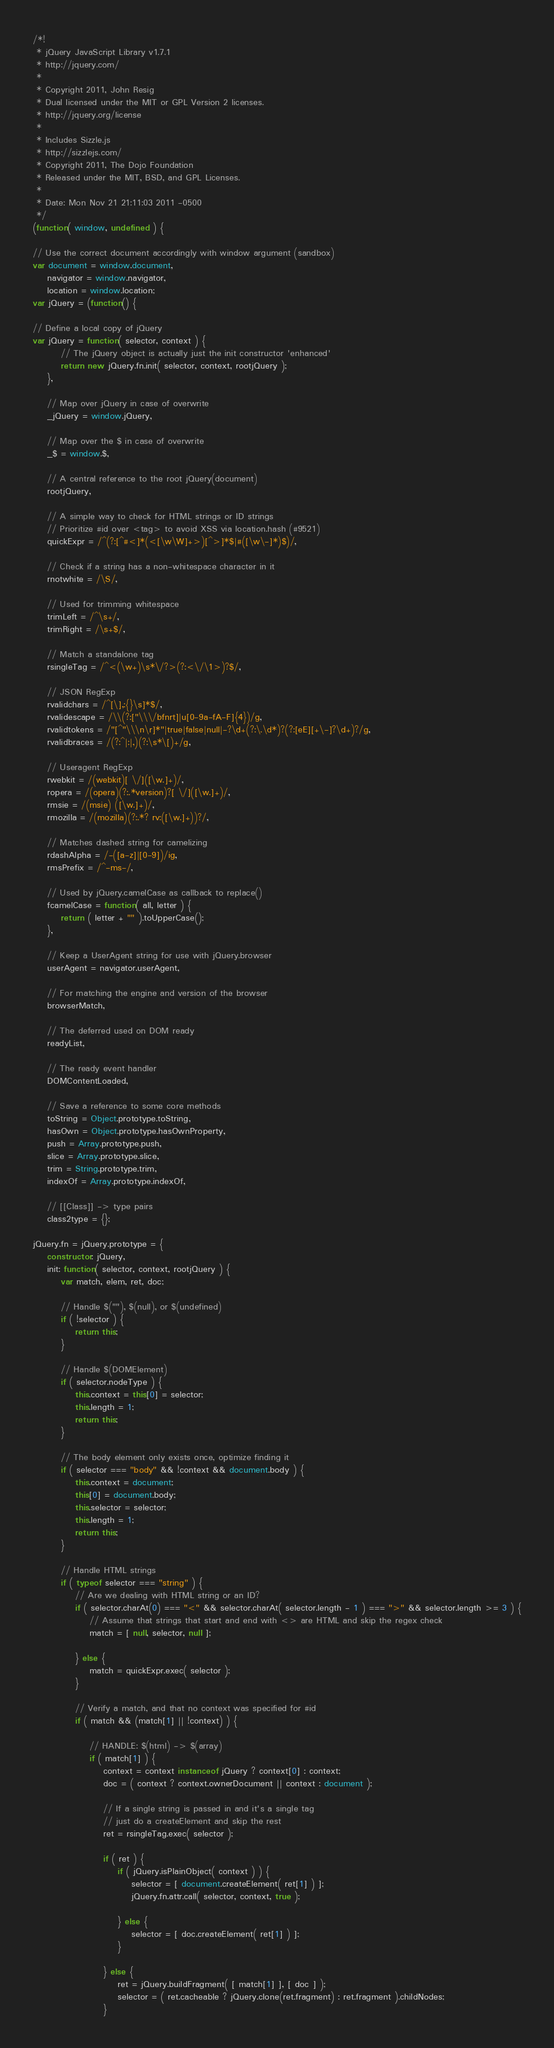Convert code to text. <code><loc_0><loc_0><loc_500><loc_500><_JavaScript_>/*!
 * jQuery JavaScript Library v1.7.1
 * http://jquery.com/
 *
 * Copyright 2011, John Resig
 * Dual licensed under the MIT or GPL Version 2 licenses.
 * http://jquery.org/license
 *
 * Includes Sizzle.js
 * http://sizzlejs.com/
 * Copyright 2011, The Dojo Foundation
 * Released under the MIT, BSD, and GPL Licenses.
 *
 * Date: Mon Nov 21 21:11:03 2011 -0500
 */
(function( window, undefined ) {

// Use the correct document accordingly with window argument (sandbox)
var document = window.document,
	navigator = window.navigator,
	location = window.location;
var jQuery = (function() {

// Define a local copy of jQuery
var jQuery = function( selector, context ) {
		// The jQuery object is actually just the init constructor 'enhanced'
		return new jQuery.fn.init( selector, context, rootjQuery );
	},

	// Map over jQuery in case of overwrite
	_jQuery = window.jQuery,

	// Map over the $ in case of overwrite
	_$ = window.$,

	// A central reference to the root jQuery(document)
	rootjQuery,

	// A simple way to check for HTML strings or ID strings
	// Prioritize #id over <tag> to avoid XSS via location.hash (#9521)
	quickExpr = /^(?:[^#<]*(<[\w\W]+>)[^>]*$|#([\w\-]*)$)/,

	// Check if a string has a non-whitespace character in it
	rnotwhite = /\S/,

	// Used for trimming whitespace
	trimLeft = /^\s+/,
	trimRight = /\s+$/,

	// Match a standalone tag
	rsingleTag = /^<(\w+)\s*\/?>(?:<\/\1>)?$/,

	// JSON RegExp
	rvalidchars = /^[\],:{}\s]*$/,
	rvalidescape = /\\(?:["\\\/bfnrt]|u[0-9a-fA-F]{4})/g,
	rvalidtokens = /"[^"\\\n\r]*"|true|false|null|-?\d+(?:\.\d*)?(?:[eE][+\-]?\d+)?/g,
	rvalidbraces = /(?:^|:|,)(?:\s*\[)+/g,

	// Useragent RegExp
	rwebkit = /(webkit)[ \/]([\w.]+)/,
	ropera = /(opera)(?:.*version)?[ \/]([\w.]+)/,
	rmsie = /(msie) ([\w.]+)/,
	rmozilla = /(mozilla)(?:.*? rv:([\w.]+))?/,

	// Matches dashed string for camelizing
	rdashAlpha = /-([a-z]|[0-9])/ig,
	rmsPrefix = /^-ms-/,

	// Used by jQuery.camelCase as callback to replace()
	fcamelCase = function( all, letter ) {
		return ( letter + "" ).toUpperCase();
	},

	// Keep a UserAgent string for use with jQuery.browser
	userAgent = navigator.userAgent,

	// For matching the engine and version of the browser
	browserMatch,

	// The deferred used on DOM ready
	readyList,

	// The ready event handler
	DOMContentLoaded,

	// Save a reference to some core methods
	toString = Object.prototype.toString,
	hasOwn = Object.prototype.hasOwnProperty,
	push = Array.prototype.push,
	slice = Array.prototype.slice,
	trim = String.prototype.trim,
	indexOf = Array.prototype.indexOf,

	// [[Class]] -> type pairs
	class2type = {};

jQuery.fn = jQuery.prototype = {
	constructor: jQuery,
	init: function( selector, context, rootjQuery ) {
		var match, elem, ret, doc;

		// Handle $(""), $(null), or $(undefined)
		if ( !selector ) {
			return this;
		}

		// Handle $(DOMElement)
		if ( selector.nodeType ) {
			this.context = this[0] = selector;
			this.length = 1;
			return this;
		}

		// The body element only exists once, optimize finding it
		if ( selector === "body" && !context && document.body ) {
			this.context = document;
			this[0] = document.body;
			this.selector = selector;
			this.length = 1;
			return this;
		}

		// Handle HTML strings
		if ( typeof selector === "string" ) {
			// Are we dealing with HTML string or an ID?
			if ( selector.charAt(0) === "<" && selector.charAt( selector.length - 1 ) === ">" && selector.length >= 3 ) {
				// Assume that strings that start and end with <> are HTML and skip the regex check
				match = [ null, selector, null ];

			} else {
				match = quickExpr.exec( selector );
			}

			// Verify a match, and that no context was specified for #id
			if ( match && (match[1] || !context) ) {

				// HANDLE: $(html) -> $(array)
				if ( match[1] ) {
					context = context instanceof jQuery ? context[0] : context;
					doc = ( context ? context.ownerDocument || context : document );

					// If a single string is passed in and it's a single tag
					// just do a createElement and skip the rest
					ret = rsingleTag.exec( selector );

					if ( ret ) {
						if ( jQuery.isPlainObject( context ) ) {
							selector = [ document.createElement( ret[1] ) ];
							jQuery.fn.attr.call( selector, context, true );

						} else {
							selector = [ doc.createElement( ret[1] ) ];
						}

					} else {
						ret = jQuery.buildFragment( [ match[1] ], [ doc ] );
						selector = ( ret.cacheable ? jQuery.clone(ret.fragment) : ret.fragment ).childNodes;
					}
</code> 